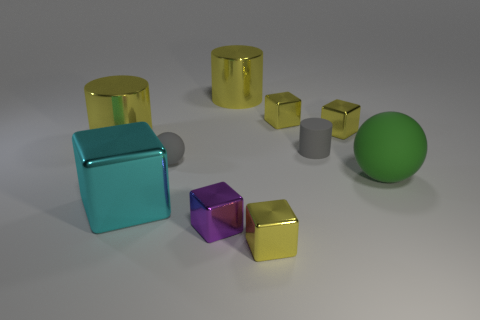Subtract all green spheres. How many yellow blocks are left? 3 Subtract all tiny purple cubes. How many cubes are left? 4 Subtract all cyan cubes. How many cubes are left? 4 Subtract all blue blocks. Subtract all yellow balls. How many blocks are left? 5 Subtract all spheres. How many objects are left? 8 Add 7 small purple metal things. How many small purple metal things are left? 8 Add 4 big cyan cubes. How many big cyan cubes exist? 5 Subtract 0 blue balls. How many objects are left? 10 Subtract all small blue matte spheres. Subtract all matte spheres. How many objects are left? 8 